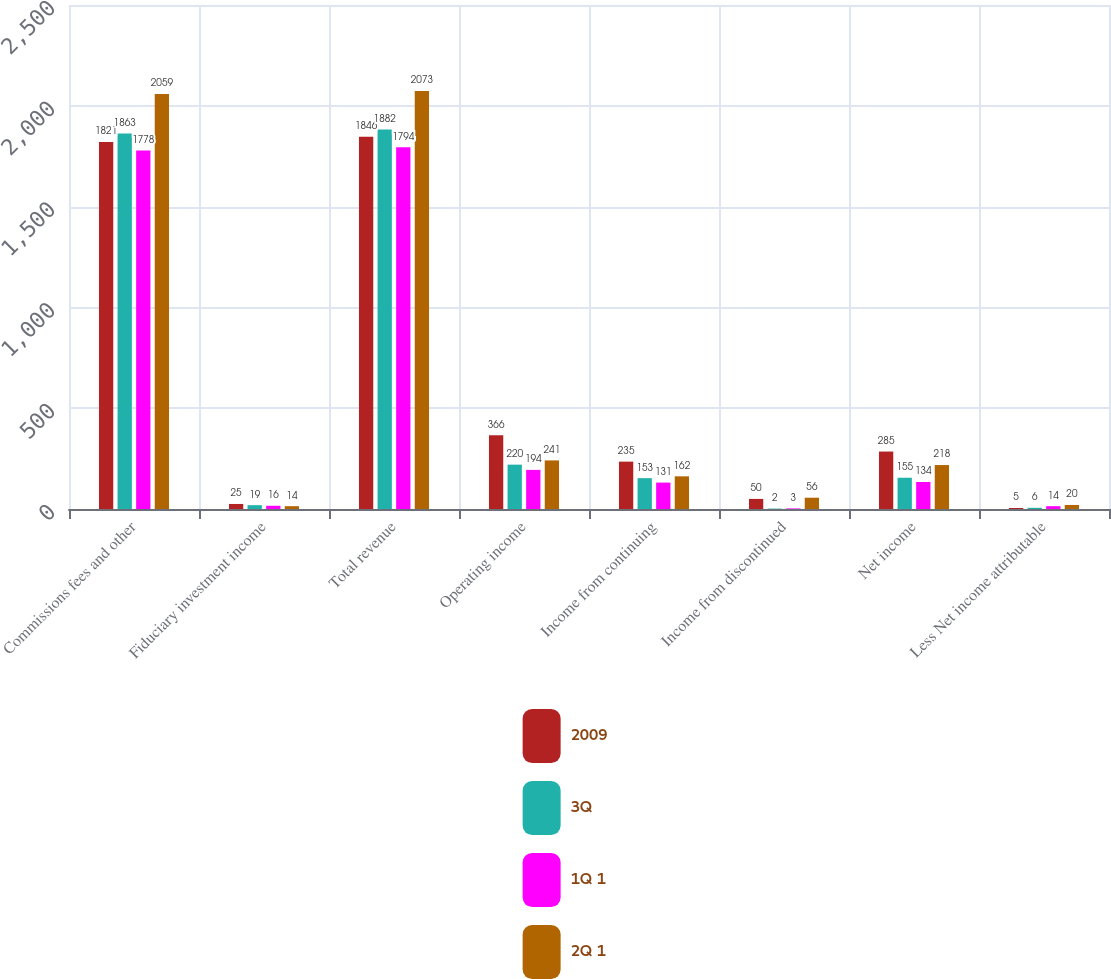Convert chart to OTSL. <chart><loc_0><loc_0><loc_500><loc_500><stacked_bar_chart><ecel><fcel>Commissions fees and other<fcel>Fiduciary investment income<fcel>Total revenue<fcel>Operating income<fcel>Income from continuing<fcel>Income from discontinued<fcel>Net income<fcel>Less Net income attributable<nl><fcel>2009<fcel>1821<fcel>25<fcel>1846<fcel>366<fcel>235<fcel>50<fcel>285<fcel>5<nl><fcel>3Q<fcel>1863<fcel>19<fcel>1882<fcel>220<fcel>153<fcel>2<fcel>155<fcel>6<nl><fcel>1Q 1<fcel>1778<fcel>16<fcel>1794<fcel>194<fcel>131<fcel>3<fcel>134<fcel>14<nl><fcel>2Q 1<fcel>2059<fcel>14<fcel>2073<fcel>241<fcel>162<fcel>56<fcel>218<fcel>20<nl></chart> 